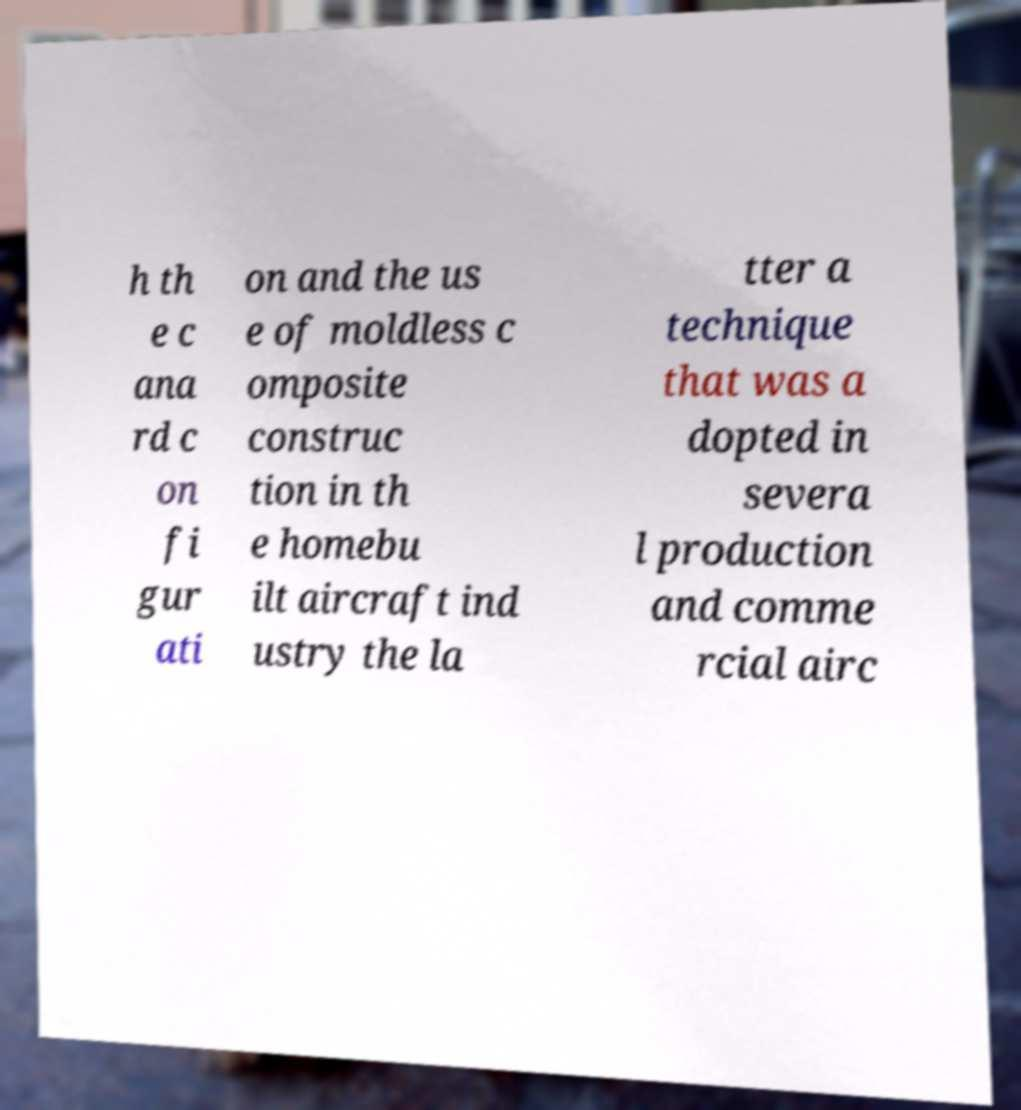Could you assist in decoding the text presented in this image and type it out clearly? h th e c ana rd c on fi gur ati on and the us e of moldless c omposite construc tion in th e homebu ilt aircraft ind ustry the la tter a technique that was a dopted in severa l production and comme rcial airc 